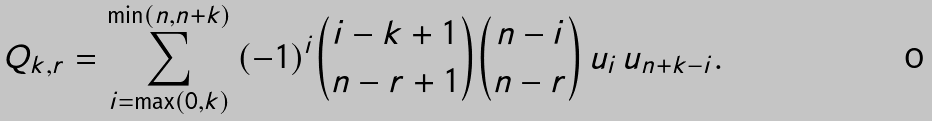Convert formula to latex. <formula><loc_0><loc_0><loc_500><loc_500>Q _ { k , r } = \sum _ { i = \max ( 0 , k ) } ^ { \min ( n , n + k ) } \, ( - 1 ) ^ { i } \binom { i - k + 1 } { n - r + 1 } \binom { n - i } { n - r } \, u _ { i } \, u _ { n + k - i } .</formula> 